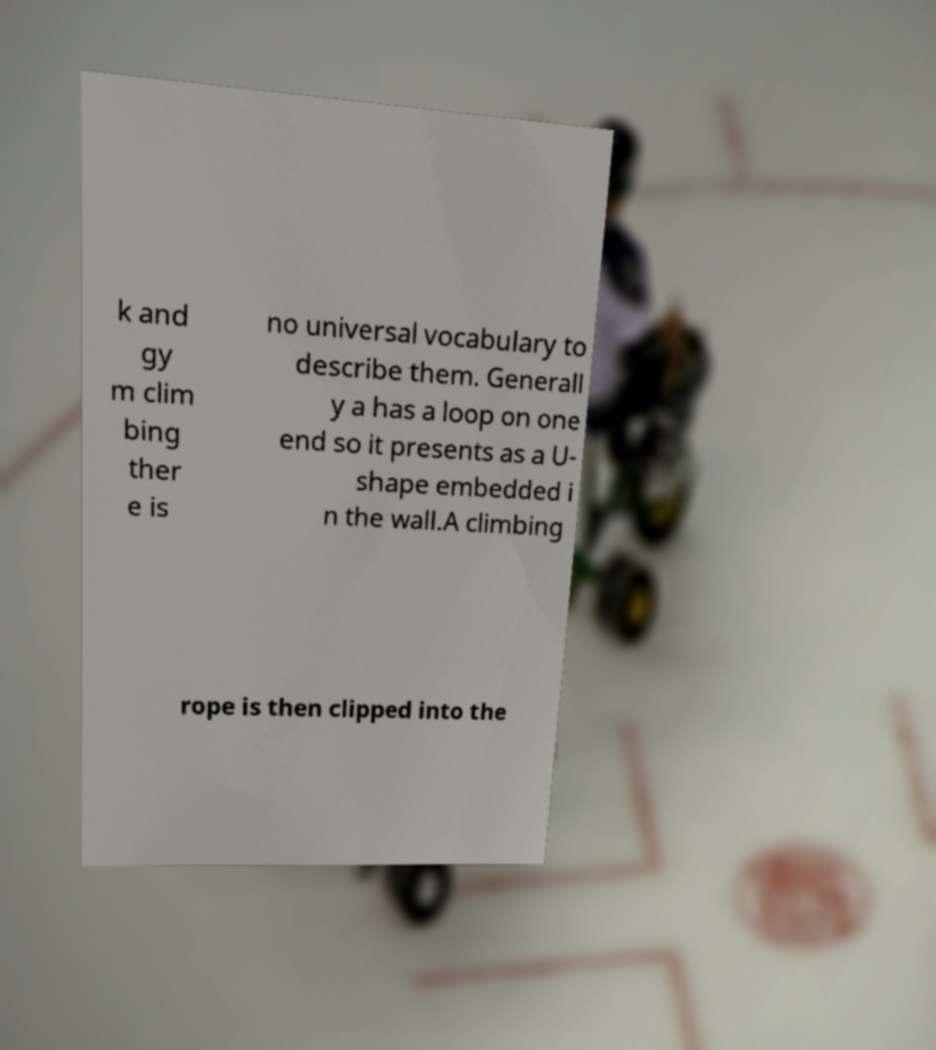Could you extract and type out the text from this image? k and gy m clim bing ther e is no universal vocabulary to describe them. Generall y a has a loop on one end so it presents as a U- shape embedded i n the wall.A climbing rope is then clipped into the 